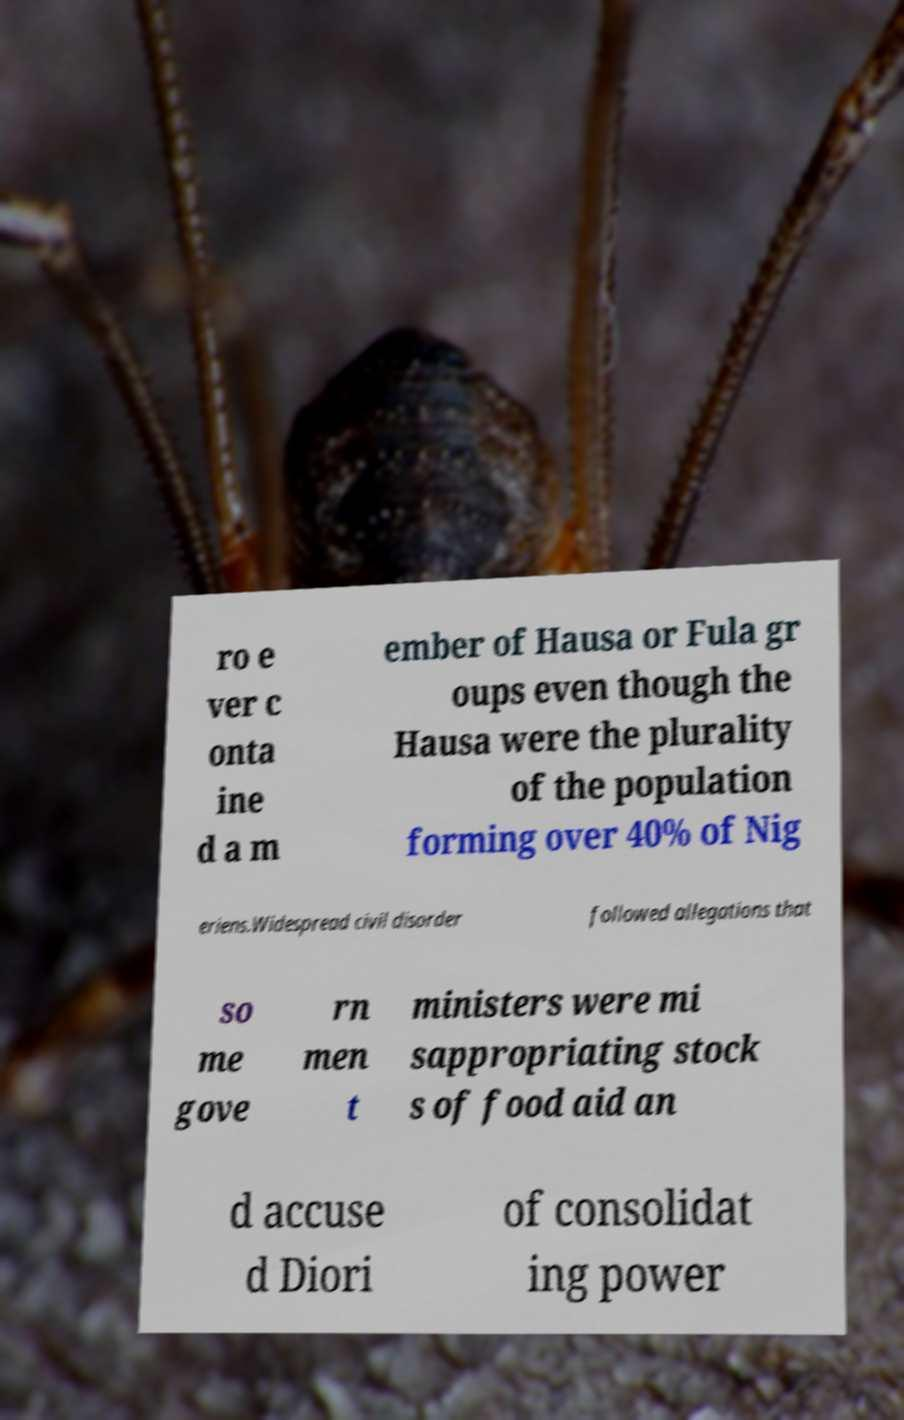For documentation purposes, I need the text within this image transcribed. Could you provide that? ro e ver c onta ine d a m ember of Hausa or Fula gr oups even though the Hausa were the plurality of the population forming over 40% of Nig eriens.Widespread civil disorder followed allegations that so me gove rn men t ministers were mi sappropriating stock s of food aid an d accuse d Diori of consolidat ing power 